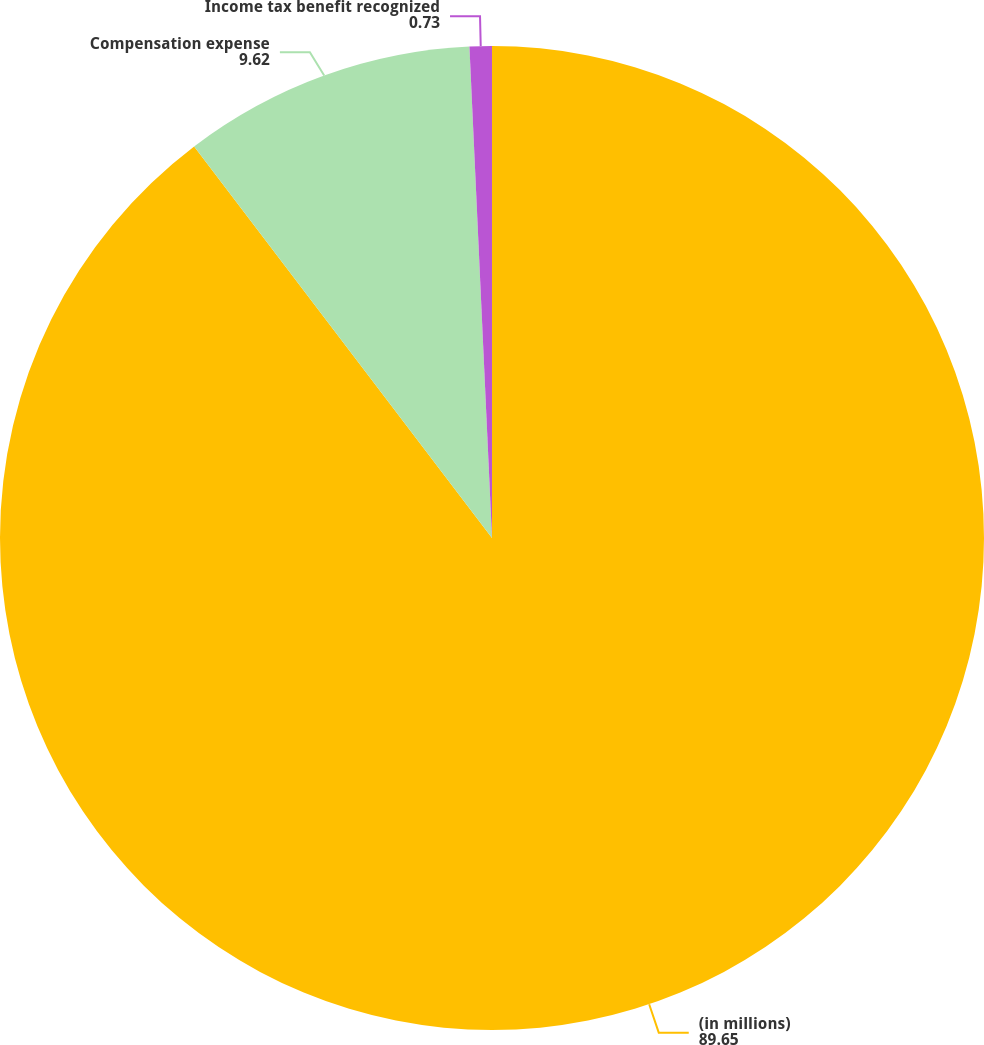Convert chart to OTSL. <chart><loc_0><loc_0><loc_500><loc_500><pie_chart><fcel>(in millions)<fcel>Compensation expense<fcel>Income tax benefit recognized<nl><fcel>89.65%<fcel>9.62%<fcel>0.73%<nl></chart> 